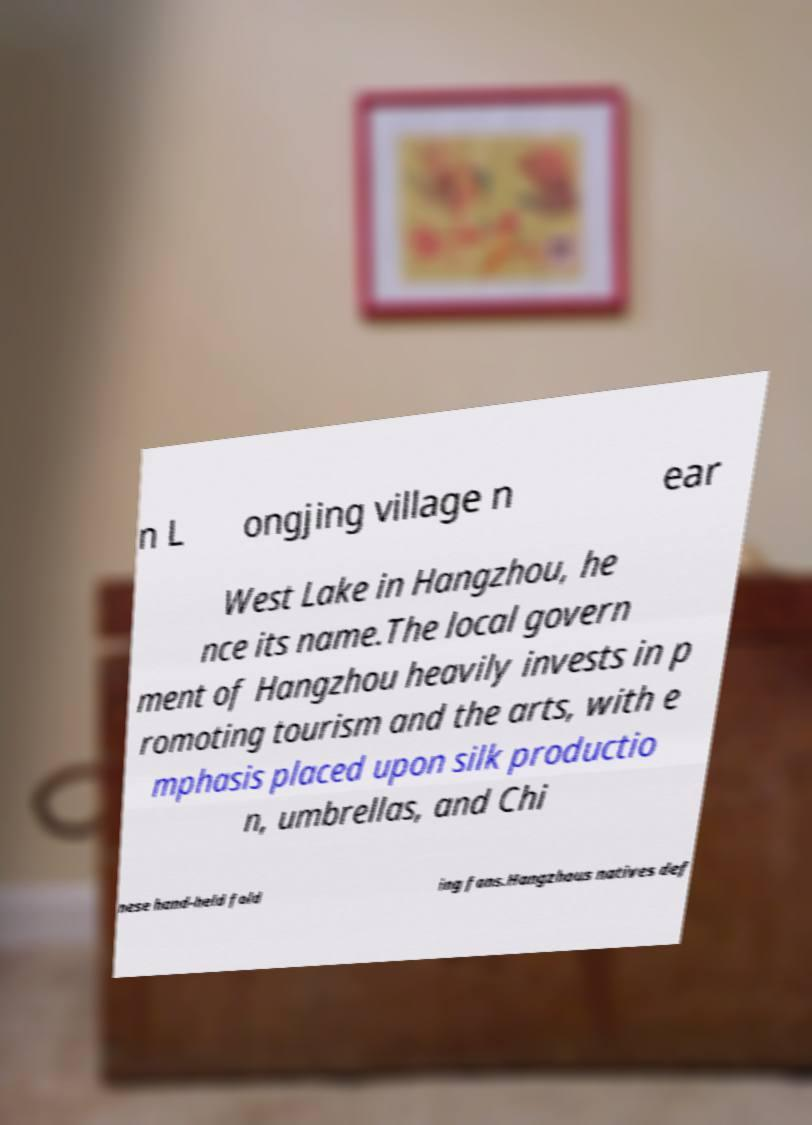I need the written content from this picture converted into text. Can you do that? n L ongjing village n ear West Lake in Hangzhou, he nce its name.The local govern ment of Hangzhou heavily invests in p romoting tourism and the arts, with e mphasis placed upon silk productio n, umbrellas, and Chi nese hand-held fold ing fans.Hangzhous natives def 